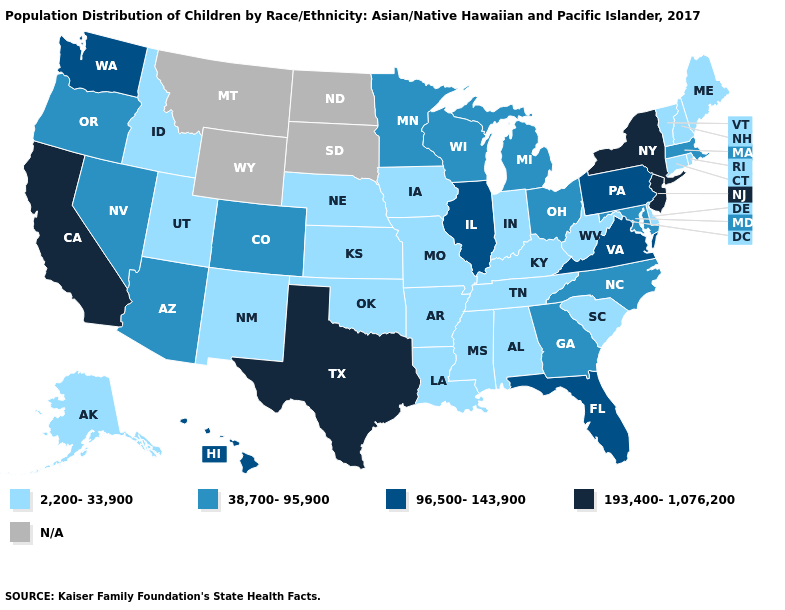Does the first symbol in the legend represent the smallest category?
Answer briefly. Yes. Which states have the highest value in the USA?
Concise answer only. California, New Jersey, New York, Texas. What is the lowest value in the USA?
Give a very brief answer. 2,200-33,900. Name the states that have a value in the range 193,400-1,076,200?
Be succinct. California, New Jersey, New York, Texas. Name the states that have a value in the range 2,200-33,900?
Keep it brief. Alabama, Alaska, Arkansas, Connecticut, Delaware, Idaho, Indiana, Iowa, Kansas, Kentucky, Louisiana, Maine, Mississippi, Missouri, Nebraska, New Hampshire, New Mexico, Oklahoma, Rhode Island, South Carolina, Tennessee, Utah, Vermont, West Virginia. Name the states that have a value in the range N/A?
Give a very brief answer. Montana, North Dakota, South Dakota, Wyoming. How many symbols are there in the legend?
Quick response, please. 5. Name the states that have a value in the range 96,500-143,900?
Give a very brief answer. Florida, Hawaii, Illinois, Pennsylvania, Virginia, Washington. What is the value of Arizona?
Quick response, please. 38,700-95,900. Name the states that have a value in the range 193,400-1,076,200?
Short answer required. California, New Jersey, New York, Texas. Name the states that have a value in the range 96,500-143,900?
Concise answer only. Florida, Hawaii, Illinois, Pennsylvania, Virginia, Washington. What is the lowest value in the Northeast?
Write a very short answer. 2,200-33,900. What is the value of Maine?
Give a very brief answer. 2,200-33,900. Does California have the highest value in the West?
Answer briefly. Yes. Does the first symbol in the legend represent the smallest category?
Give a very brief answer. Yes. 